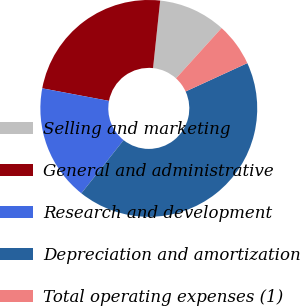Convert chart. <chart><loc_0><loc_0><loc_500><loc_500><pie_chart><fcel>Selling and marketing<fcel>General and administrative<fcel>Research and development<fcel>Depreciation and amortization<fcel>Total operating expenses (1)<nl><fcel>10.04%<fcel>23.71%<fcel>17.28%<fcel>42.54%<fcel>6.43%<nl></chart> 